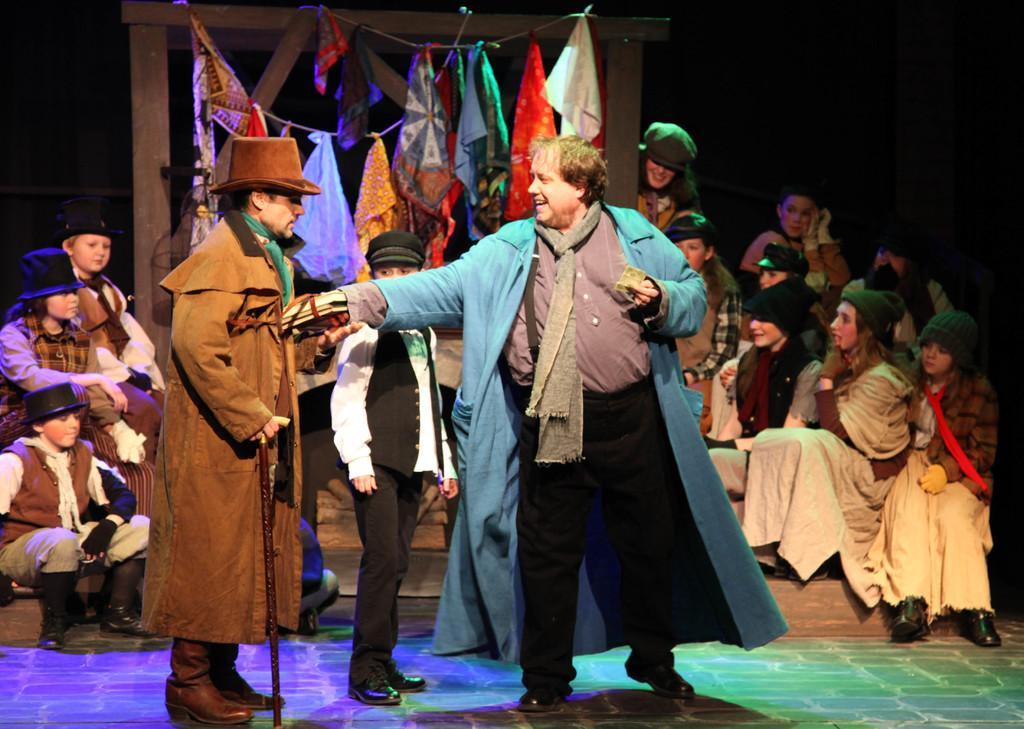Please provide a concise description of this image. In this image we can see some group of persons sitting on stairs, in the foreground of the image there are two persons wearing blue and brown color suits standing and in the background of the image there are some handkerchiefs hanged to the hanger. 